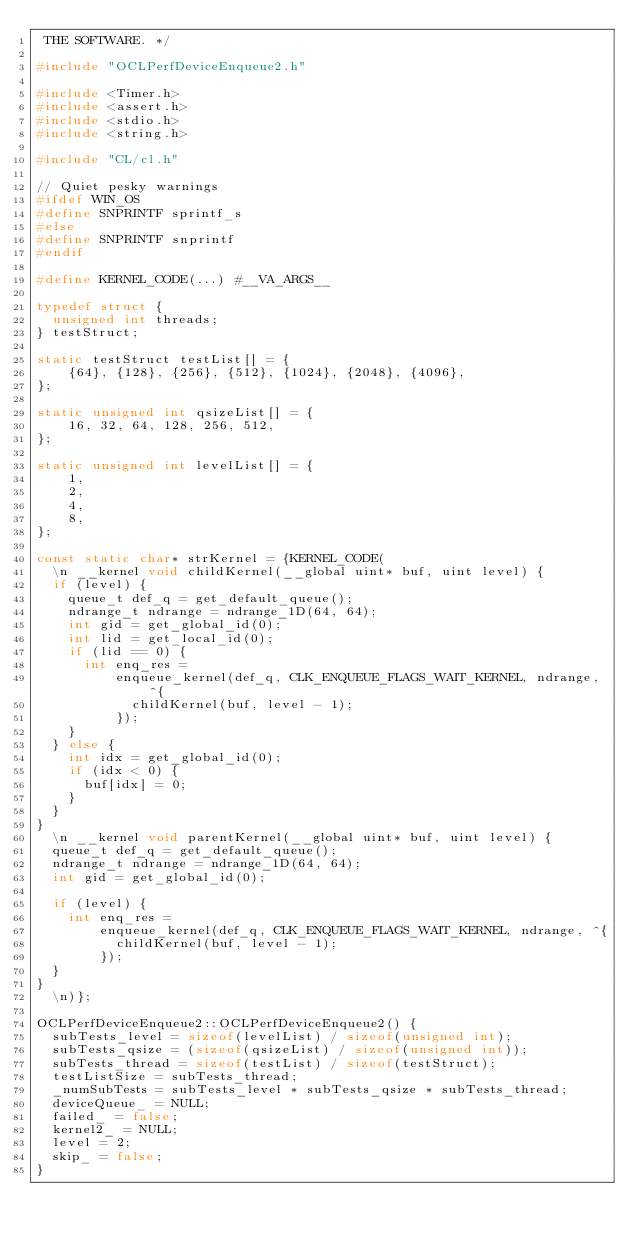Convert code to text. <code><loc_0><loc_0><loc_500><loc_500><_C++_> THE SOFTWARE. */

#include "OCLPerfDeviceEnqueue2.h"

#include <Timer.h>
#include <assert.h>
#include <stdio.h>
#include <string.h>

#include "CL/cl.h"

// Quiet pesky warnings
#ifdef WIN_OS
#define SNPRINTF sprintf_s
#else
#define SNPRINTF snprintf
#endif

#define KERNEL_CODE(...) #__VA_ARGS__

typedef struct {
  unsigned int threads;
} testStruct;

static testStruct testList[] = {
    {64}, {128}, {256}, {512}, {1024}, {2048}, {4096},
};

static unsigned int qsizeList[] = {
    16, 32, 64, 128, 256, 512,
};

static unsigned int levelList[] = {
    1,
    2,
    4,
    8,
};

const static char* strKernel = {KERNEL_CODE(
  \n __kernel void childKernel(__global uint* buf, uint level) {
  if (level) {
    queue_t def_q = get_default_queue();
    ndrange_t ndrange = ndrange_1D(64, 64);
    int gid = get_global_id(0);
    int lid = get_local_id(0);
    if (lid == 0) {
      int enq_res =
          enqueue_kernel(def_q, CLK_ENQUEUE_FLAGS_WAIT_KERNEL, ndrange, ^{
            childKernel(buf, level - 1);
          });
    }
  } else {
    int idx = get_global_id(0);
    if (idx < 0) {
      buf[idx] = 0;
    }
  }
}
  \n __kernel void parentKernel(__global uint* buf, uint level) {
  queue_t def_q = get_default_queue();
  ndrange_t ndrange = ndrange_1D(64, 64);
  int gid = get_global_id(0);

  if (level) {
    int enq_res =
        enqueue_kernel(def_q, CLK_ENQUEUE_FLAGS_WAIT_KERNEL, ndrange, ^{
          childKernel(buf, level - 1);
        });
  }
}
  \n)};

OCLPerfDeviceEnqueue2::OCLPerfDeviceEnqueue2() {
  subTests_level = sizeof(levelList) / sizeof(unsigned int);
  subTests_qsize = (sizeof(qsizeList) / sizeof(unsigned int));
  subTests_thread = sizeof(testList) / sizeof(testStruct);
  testListSize = subTests_thread;
  _numSubTests = subTests_level * subTests_qsize * subTests_thread;
  deviceQueue_ = NULL;
  failed_ = false;
  kernel2_ = NULL;
  level = 2;
  skip_ = false;
}
</code> 